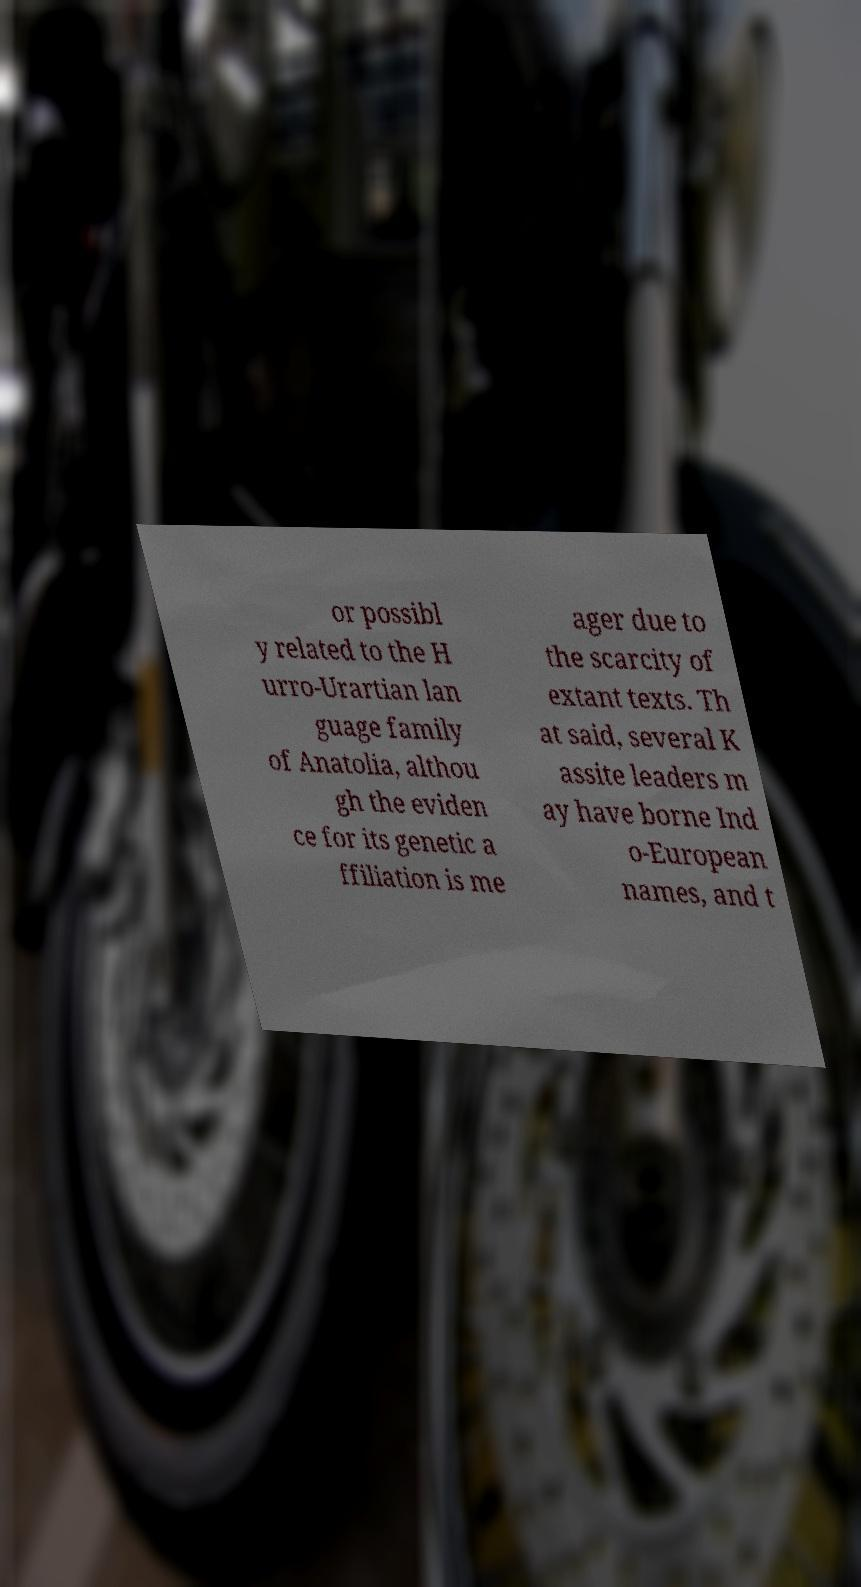Could you assist in decoding the text presented in this image and type it out clearly? or possibl y related to the H urro-Urartian lan guage family of Anatolia, althou gh the eviden ce for its genetic a ffiliation is me ager due to the scarcity of extant texts. Th at said, several K assite leaders m ay have borne Ind o-European names, and t 